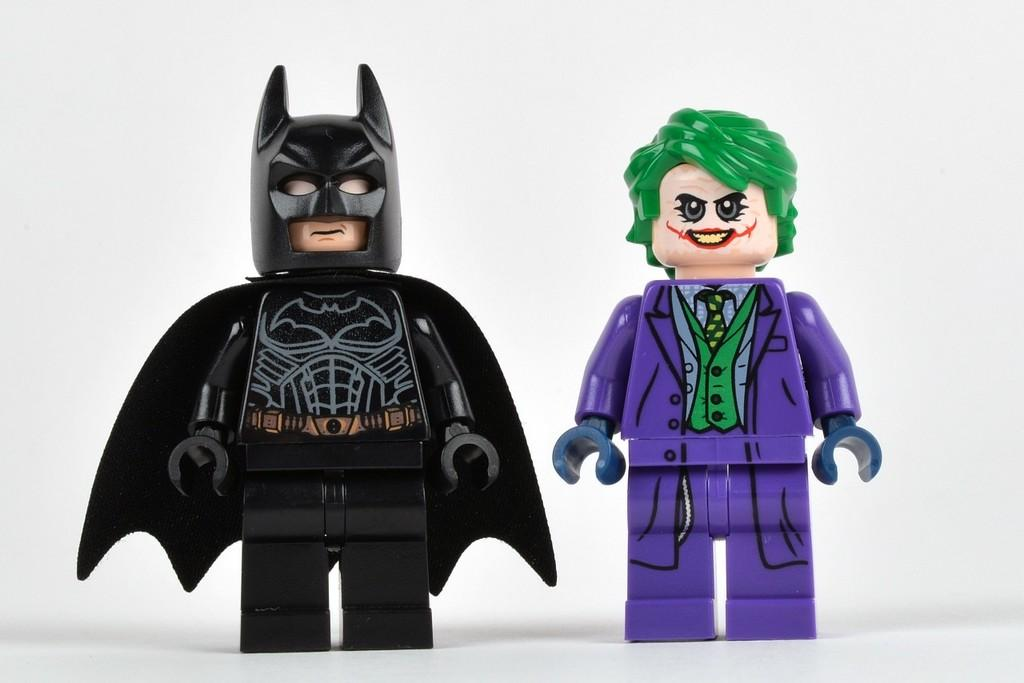How many toys are present in the image? There are two toys in the image. What colors are featured on the toys' dresses? The toys are wearing black, purple, and green color dresses. What is the color of the background in the image? The background of the image is white. Can you tell me how many doors are visible in the image? There are no doors present in the image; it features two toys wearing colorful dresses against a white background. What type of cap is the toy wearing in the image? There is no cap visible on the toys in the image; they are wearing dresses. 